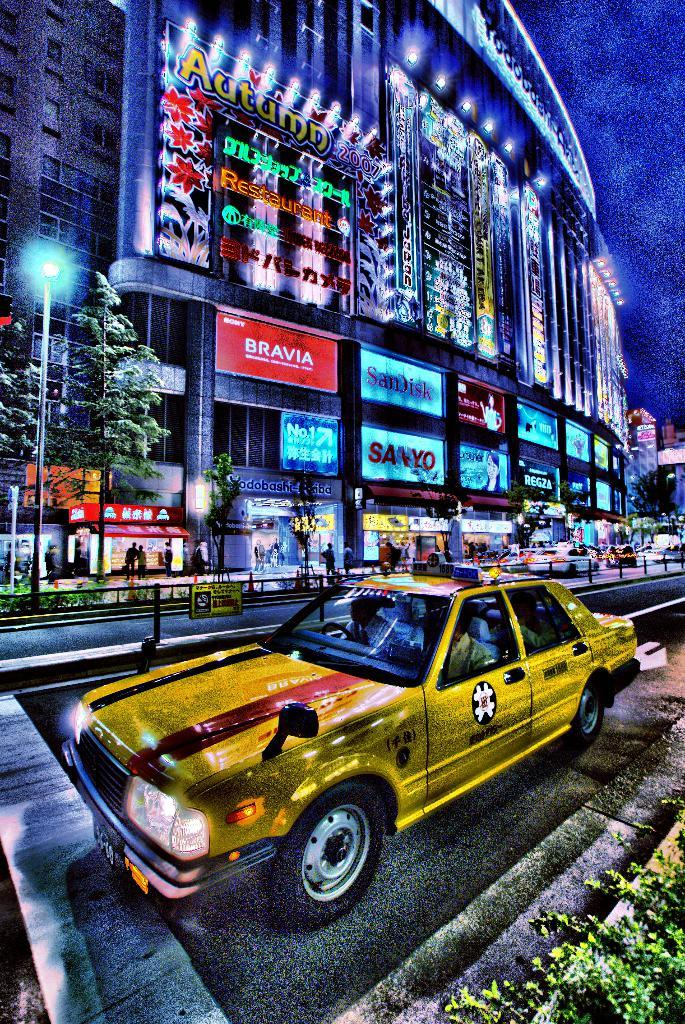<image>
Offer a succinct explanation of the picture presented. A yellow car parked on a street in front of a city building with signs lit up on it such as Bravia, SanDisk, Sanyo along with many others. 